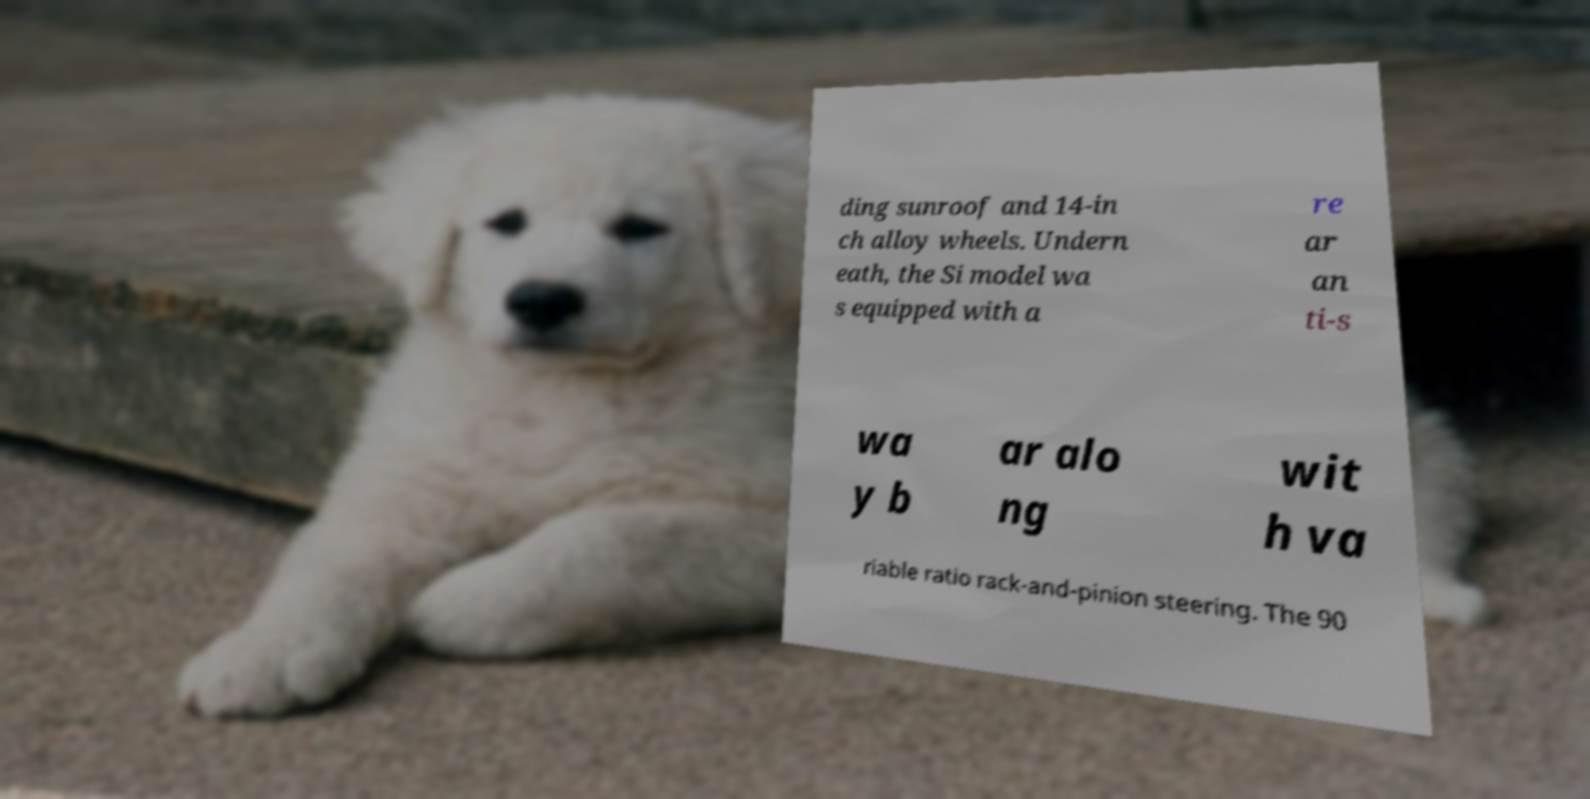What messages or text are displayed in this image? I need them in a readable, typed format. ding sunroof and 14-in ch alloy wheels. Undern eath, the Si model wa s equipped with a re ar an ti-s wa y b ar alo ng wit h va riable ratio rack-and-pinion steering. The 90 